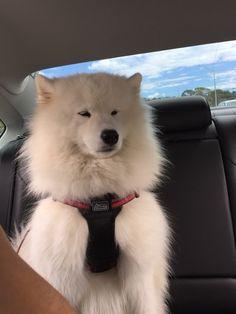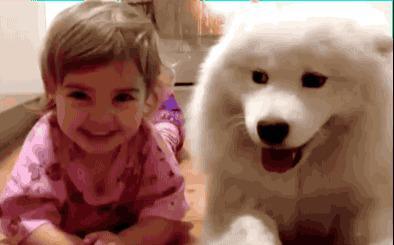The first image is the image on the left, the second image is the image on the right. For the images shown, is this caption "At least one image shows a person next to a big white dog." true? Answer yes or no. Yes. The first image is the image on the left, the second image is the image on the right. Given the left and right images, does the statement "A person is posing with a white dog." hold true? Answer yes or no. Yes. 